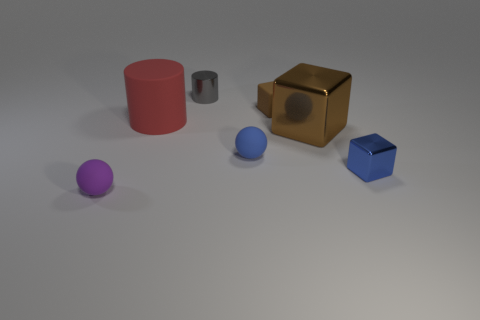There is a tiny shiny object behind the big red rubber cylinder; is it the same shape as the small metal object on the right side of the small brown thing?
Your response must be concise. No. What is the shape of the small object to the left of the large object that is left of the rubber sphere that is on the right side of the purple matte object?
Your answer should be very brief. Sphere. What is the size of the red object?
Make the answer very short. Large. The gray object that is made of the same material as the big brown block is what shape?
Provide a short and direct response. Cylinder. Are there fewer big rubber things on the right side of the blue metallic object than large things?
Your answer should be compact. Yes. What color is the large thing that is on the left side of the small gray thing?
Keep it short and to the point. Red. What is the material of the cube that is the same color as the large shiny object?
Your answer should be very brief. Rubber. Are there any big metallic objects of the same shape as the tiny blue rubber object?
Provide a succinct answer. No. How many blue matte objects have the same shape as the small purple matte thing?
Ensure brevity in your answer.  1. Do the big metal block and the rubber cube have the same color?
Your answer should be very brief. Yes. 